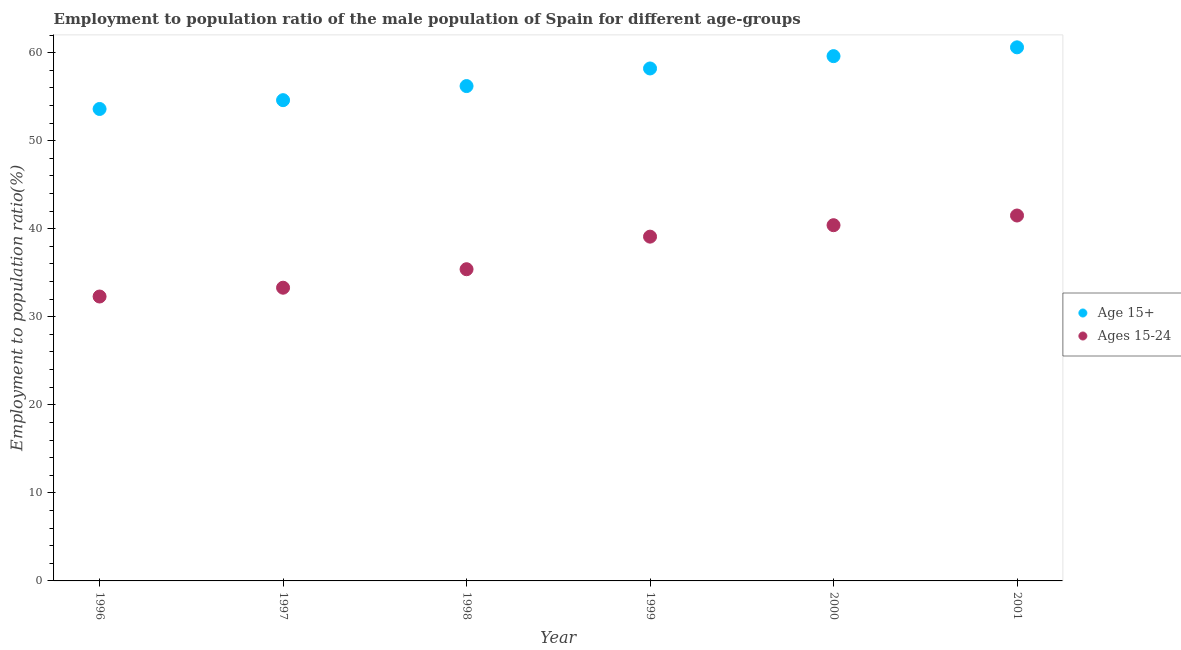How many different coloured dotlines are there?
Your answer should be compact. 2. Is the number of dotlines equal to the number of legend labels?
Give a very brief answer. Yes. What is the employment to population ratio(age 15-24) in 1999?
Your response must be concise. 39.1. Across all years, what is the maximum employment to population ratio(age 15-24)?
Offer a very short reply. 41.5. Across all years, what is the minimum employment to population ratio(age 15+)?
Keep it short and to the point. 53.6. In which year was the employment to population ratio(age 15-24) maximum?
Provide a succinct answer. 2001. In which year was the employment to population ratio(age 15-24) minimum?
Your answer should be very brief. 1996. What is the total employment to population ratio(age 15-24) in the graph?
Give a very brief answer. 222. What is the difference between the employment to population ratio(age 15+) in 1999 and that in 2000?
Your response must be concise. -1.4. What is the difference between the employment to population ratio(age 15-24) in 2001 and the employment to population ratio(age 15+) in 1999?
Your answer should be compact. -16.7. What is the average employment to population ratio(age 15+) per year?
Give a very brief answer. 57.13. In the year 2001, what is the difference between the employment to population ratio(age 15-24) and employment to population ratio(age 15+)?
Ensure brevity in your answer.  -19.1. In how many years, is the employment to population ratio(age 15+) greater than 34 %?
Provide a short and direct response. 6. What is the ratio of the employment to population ratio(age 15+) in 1997 to that in 1999?
Make the answer very short. 0.94. Is the employment to population ratio(age 15-24) in 1997 less than that in 1999?
Provide a short and direct response. Yes. Is the difference between the employment to population ratio(age 15+) in 1996 and 1999 greater than the difference between the employment to population ratio(age 15-24) in 1996 and 1999?
Offer a terse response. Yes. What is the difference between the highest and the second highest employment to population ratio(age 15-24)?
Offer a terse response. 1.1. Does the employment to population ratio(age 15-24) monotonically increase over the years?
Make the answer very short. Yes. What is the difference between two consecutive major ticks on the Y-axis?
Offer a very short reply. 10. Are the values on the major ticks of Y-axis written in scientific E-notation?
Provide a short and direct response. No. Does the graph contain grids?
Ensure brevity in your answer.  No. How many legend labels are there?
Make the answer very short. 2. How are the legend labels stacked?
Your answer should be compact. Vertical. What is the title of the graph?
Offer a terse response. Employment to population ratio of the male population of Spain for different age-groups. Does "Canada" appear as one of the legend labels in the graph?
Ensure brevity in your answer.  No. What is the label or title of the Y-axis?
Your response must be concise. Employment to population ratio(%). What is the Employment to population ratio(%) in Age 15+ in 1996?
Provide a short and direct response. 53.6. What is the Employment to population ratio(%) of Ages 15-24 in 1996?
Provide a short and direct response. 32.3. What is the Employment to population ratio(%) in Age 15+ in 1997?
Your answer should be compact. 54.6. What is the Employment to population ratio(%) in Ages 15-24 in 1997?
Your answer should be very brief. 33.3. What is the Employment to population ratio(%) in Age 15+ in 1998?
Ensure brevity in your answer.  56.2. What is the Employment to population ratio(%) of Ages 15-24 in 1998?
Offer a very short reply. 35.4. What is the Employment to population ratio(%) of Age 15+ in 1999?
Keep it short and to the point. 58.2. What is the Employment to population ratio(%) of Ages 15-24 in 1999?
Make the answer very short. 39.1. What is the Employment to population ratio(%) of Age 15+ in 2000?
Provide a short and direct response. 59.6. What is the Employment to population ratio(%) in Ages 15-24 in 2000?
Offer a very short reply. 40.4. What is the Employment to population ratio(%) in Age 15+ in 2001?
Your response must be concise. 60.6. What is the Employment to population ratio(%) in Ages 15-24 in 2001?
Offer a terse response. 41.5. Across all years, what is the maximum Employment to population ratio(%) in Age 15+?
Your answer should be very brief. 60.6. Across all years, what is the maximum Employment to population ratio(%) of Ages 15-24?
Your answer should be compact. 41.5. Across all years, what is the minimum Employment to population ratio(%) in Age 15+?
Provide a succinct answer. 53.6. Across all years, what is the minimum Employment to population ratio(%) in Ages 15-24?
Provide a short and direct response. 32.3. What is the total Employment to population ratio(%) in Age 15+ in the graph?
Your answer should be very brief. 342.8. What is the total Employment to population ratio(%) in Ages 15-24 in the graph?
Offer a terse response. 222. What is the difference between the Employment to population ratio(%) of Age 15+ in 1996 and that in 1998?
Your answer should be very brief. -2.6. What is the difference between the Employment to population ratio(%) in Ages 15-24 in 1996 and that in 1998?
Ensure brevity in your answer.  -3.1. What is the difference between the Employment to population ratio(%) in Age 15+ in 1996 and that in 2000?
Give a very brief answer. -6. What is the difference between the Employment to population ratio(%) in Age 15+ in 1997 and that in 1999?
Your answer should be very brief. -3.6. What is the difference between the Employment to population ratio(%) in Age 15+ in 1997 and that in 2000?
Give a very brief answer. -5. What is the difference between the Employment to population ratio(%) in Age 15+ in 1997 and that in 2001?
Your answer should be compact. -6. What is the difference between the Employment to population ratio(%) in Age 15+ in 1998 and that in 1999?
Provide a succinct answer. -2. What is the difference between the Employment to population ratio(%) in Ages 15-24 in 1998 and that in 1999?
Provide a succinct answer. -3.7. What is the difference between the Employment to population ratio(%) of Age 15+ in 1998 and that in 2001?
Give a very brief answer. -4.4. What is the difference between the Employment to population ratio(%) in Ages 15-24 in 1998 and that in 2001?
Ensure brevity in your answer.  -6.1. What is the difference between the Employment to population ratio(%) in Ages 15-24 in 1999 and that in 2000?
Offer a very short reply. -1.3. What is the difference between the Employment to population ratio(%) of Age 15+ in 1999 and that in 2001?
Provide a succinct answer. -2.4. What is the difference between the Employment to population ratio(%) of Ages 15-24 in 1999 and that in 2001?
Offer a very short reply. -2.4. What is the difference between the Employment to population ratio(%) of Ages 15-24 in 2000 and that in 2001?
Provide a short and direct response. -1.1. What is the difference between the Employment to population ratio(%) of Age 15+ in 1996 and the Employment to population ratio(%) of Ages 15-24 in 1997?
Your answer should be compact. 20.3. What is the difference between the Employment to population ratio(%) in Age 15+ in 1996 and the Employment to population ratio(%) in Ages 15-24 in 2000?
Ensure brevity in your answer.  13.2. What is the difference between the Employment to population ratio(%) in Age 15+ in 1997 and the Employment to population ratio(%) in Ages 15-24 in 1998?
Make the answer very short. 19.2. What is the difference between the Employment to population ratio(%) of Age 15+ in 1998 and the Employment to population ratio(%) of Ages 15-24 in 2000?
Your answer should be compact. 15.8. What is the difference between the Employment to population ratio(%) of Age 15+ in 1999 and the Employment to population ratio(%) of Ages 15-24 in 2000?
Your response must be concise. 17.8. What is the difference between the Employment to population ratio(%) in Age 15+ in 1999 and the Employment to population ratio(%) in Ages 15-24 in 2001?
Your answer should be very brief. 16.7. What is the average Employment to population ratio(%) of Age 15+ per year?
Your answer should be compact. 57.13. In the year 1996, what is the difference between the Employment to population ratio(%) in Age 15+ and Employment to population ratio(%) in Ages 15-24?
Your response must be concise. 21.3. In the year 1997, what is the difference between the Employment to population ratio(%) of Age 15+ and Employment to population ratio(%) of Ages 15-24?
Give a very brief answer. 21.3. In the year 1998, what is the difference between the Employment to population ratio(%) of Age 15+ and Employment to population ratio(%) of Ages 15-24?
Provide a succinct answer. 20.8. In the year 2001, what is the difference between the Employment to population ratio(%) of Age 15+ and Employment to population ratio(%) of Ages 15-24?
Offer a terse response. 19.1. What is the ratio of the Employment to population ratio(%) in Age 15+ in 1996 to that in 1997?
Provide a succinct answer. 0.98. What is the ratio of the Employment to population ratio(%) in Age 15+ in 1996 to that in 1998?
Give a very brief answer. 0.95. What is the ratio of the Employment to population ratio(%) of Ages 15-24 in 1996 to that in 1998?
Your answer should be very brief. 0.91. What is the ratio of the Employment to population ratio(%) in Age 15+ in 1996 to that in 1999?
Ensure brevity in your answer.  0.92. What is the ratio of the Employment to population ratio(%) of Ages 15-24 in 1996 to that in 1999?
Provide a succinct answer. 0.83. What is the ratio of the Employment to population ratio(%) of Age 15+ in 1996 to that in 2000?
Offer a very short reply. 0.9. What is the ratio of the Employment to population ratio(%) in Ages 15-24 in 1996 to that in 2000?
Offer a terse response. 0.8. What is the ratio of the Employment to population ratio(%) of Age 15+ in 1996 to that in 2001?
Your answer should be very brief. 0.88. What is the ratio of the Employment to population ratio(%) in Ages 15-24 in 1996 to that in 2001?
Make the answer very short. 0.78. What is the ratio of the Employment to population ratio(%) of Age 15+ in 1997 to that in 1998?
Provide a succinct answer. 0.97. What is the ratio of the Employment to population ratio(%) of Ages 15-24 in 1997 to that in 1998?
Offer a terse response. 0.94. What is the ratio of the Employment to population ratio(%) in Age 15+ in 1997 to that in 1999?
Ensure brevity in your answer.  0.94. What is the ratio of the Employment to population ratio(%) in Ages 15-24 in 1997 to that in 1999?
Give a very brief answer. 0.85. What is the ratio of the Employment to population ratio(%) of Age 15+ in 1997 to that in 2000?
Give a very brief answer. 0.92. What is the ratio of the Employment to population ratio(%) in Ages 15-24 in 1997 to that in 2000?
Give a very brief answer. 0.82. What is the ratio of the Employment to population ratio(%) of Age 15+ in 1997 to that in 2001?
Keep it short and to the point. 0.9. What is the ratio of the Employment to population ratio(%) of Ages 15-24 in 1997 to that in 2001?
Offer a very short reply. 0.8. What is the ratio of the Employment to population ratio(%) of Age 15+ in 1998 to that in 1999?
Give a very brief answer. 0.97. What is the ratio of the Employment to population ratio(%) of Ages 15-24 in 1998 to that in 1999?
Your response must be concise. 0.91. What is the ratio of the Employment to population ratio(%) in Age 15+ in 1998 to that in 2000?
Your answer should be very brief. 0.94. What is the ratio of the Employment to population ratio(%) of Ages 15-24 in 1998 to that in 2000?
Your answer should be very brief. 0.88. What is the ratio of the Employment to population ratio(%) in Age 15+ in 1998 to that in 2001?
Keep it short and to the point. 0.93. What is the ratio of the Employment to population ratio(%) in Ages 15-24 in 1998 to that in 2001?
Provide a short and direct response. 0.85. What is the ratio of the Employment to population ratio(%) of Age 15+ in 1999 to that in 2000?
Keep it short and to the point. 0.98. What is the ratio of the Employment to population ratio(%) of Ages 15-24 in 1999 to that in 2000?
Ensure brevity in your answer.  0.97. What is the ratio of the Employment to population ratio(%) in Age 15+ in 1999 to that in 2001?
Ensure brevity in your answer.  0.96. What is the ratio of the Employment to population ratio(%) in Ages 15-24 in 1999 to that in 2001?
Your answer should be compact. 0.94. What is the ratio of the Employment to population ratio(%) in Age 15+ in 2000 to that in 2001?
Keep it short and to the point. 0.98. What is the ratio of the Employment to population ratio(%) in Ages 15-24 in 2000 to that in 2001?
Your response must be concise. 0.97. What is the difference between the highest and the second highest Employment to population ratio(%) in Ages 15-24?
Keep it short and to the point. 1.1. 